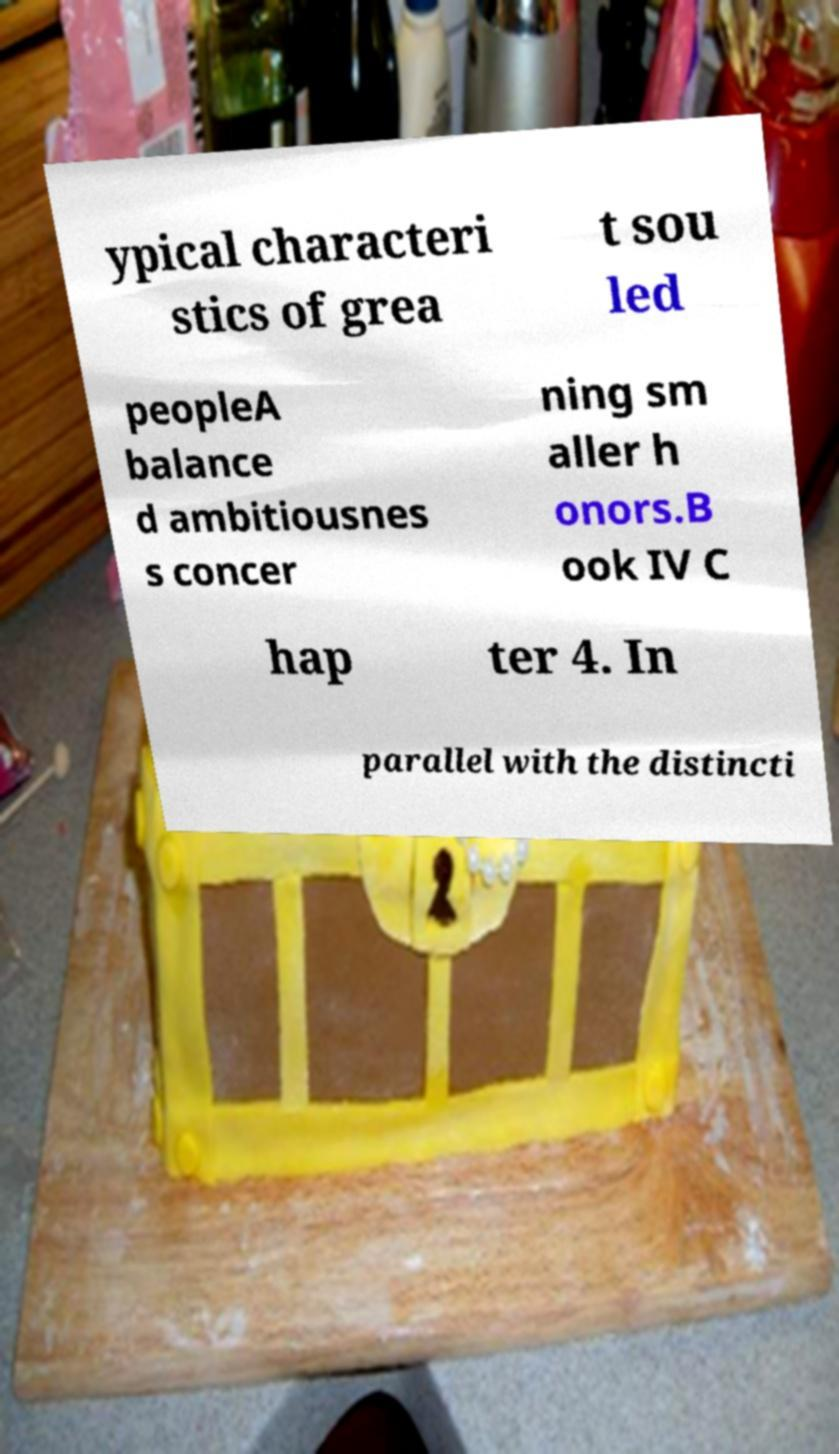What messages or text are displayed in this image? I need them in a readable, typed format. ypical characteri stics of grea t sou led peopleA balance d ambitiousnes s concer ning sm aller h onors.B ook IV C hap ter 4. In parallel with the distincti 